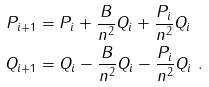Convert formula to latex. <formula><loc_0><loc_0><loc_500><loc_500>P _ { i + 1 } & = P _ { i } + \frac { B } { n ^ { 2 } } Q _ { i } + \frac { P _ { i } } { n ^ { 2 } } Q _ { i } \\ Q _ { i + 1 } & = Q _ { i } - \frac { B } { n ^ { 2 } } Q _ { i } - \frac { P _ { i } } { n ^ { 2 } } Q _ { i } \ .</formula> 